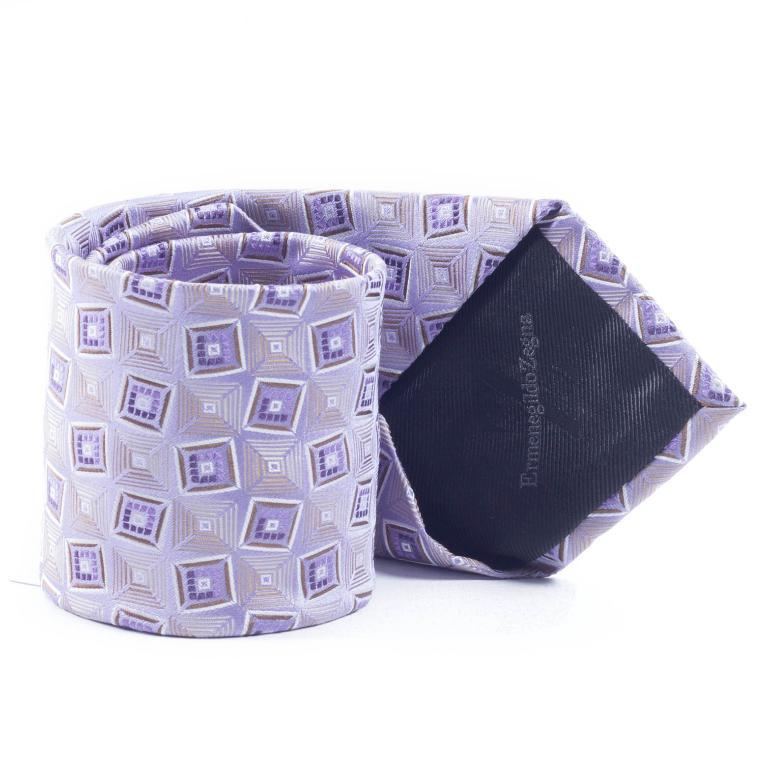What is the main object in the image? There is a rolled cloth in the image. What color is the background of the image? The background of the image is white. What type of advice does the government provide in the image? There is no mention of the government or any advice in the image; it only features a rolled cloth and a white background. 